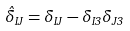<formula> <loc_0><loc_0><loc_500><loc_500>\hat { \delta } _ { I J } = \delta _ { I J } - \delta _ { I 3 } \delta _ { J 3 }</formula> 